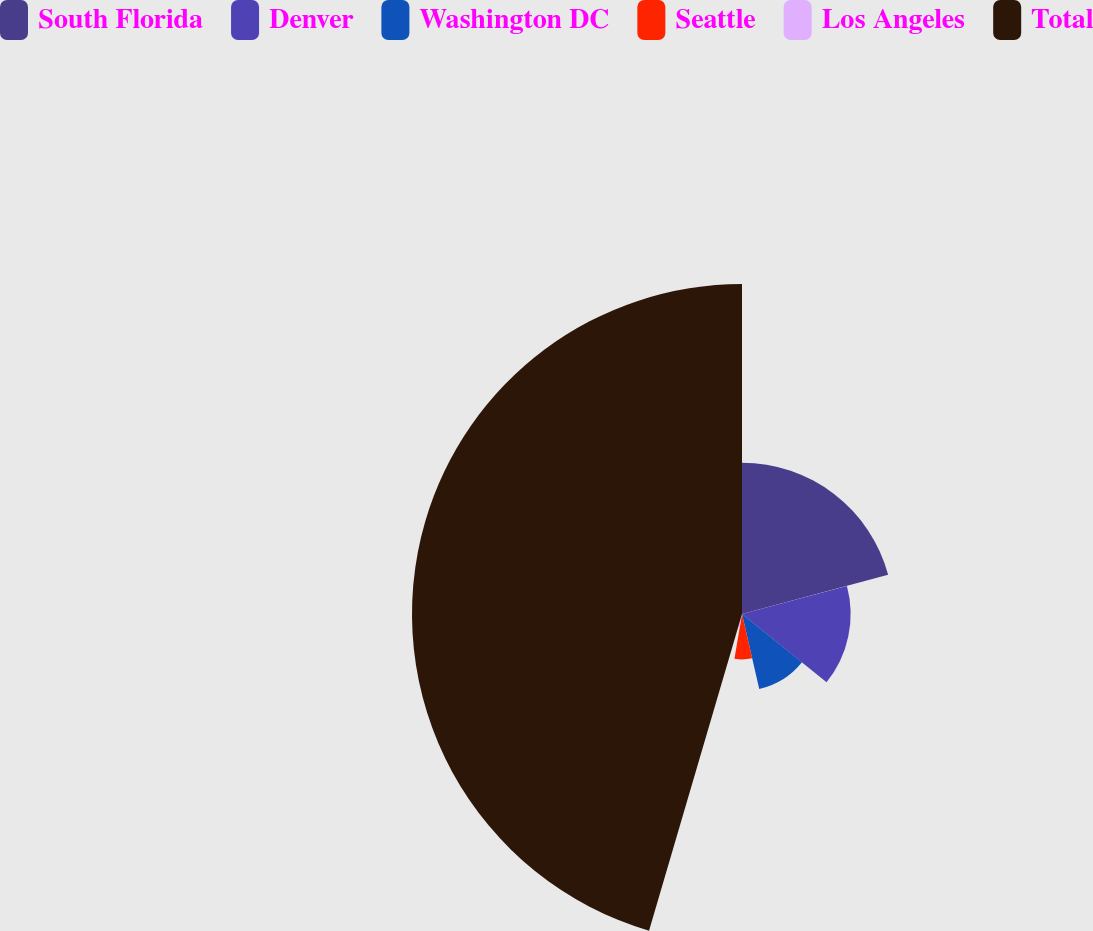<chart> <loc_0><loc_0><loc_500><loc_500><pie_chart><fcel>South Florida<fcel>Denver<fcel>Washington DC<fcel>Seattle<fcel>Los Angeles<fcel>Total<nl><fcel>20.83%<fcel>14.96%<fcel>10.61%<fcel>6.25%<fcel>1.89%<fcel>45.45%<nl></chart> 